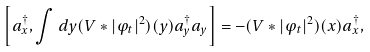<formula> <loc_0><loc_0><loc_500><loc_500>\left [ a _ { x } ^ { \dag } , \int d y ( V * | \varphi _ { t } | ^ { 2 } ) ( y ) a _ { y } ^ { \dag } a _ { y } \right ] = - ( V * | \varphi _ { t } | ^ { 2 } ) ( x ) a _ { x } ^ { \dag } ,</formula> 